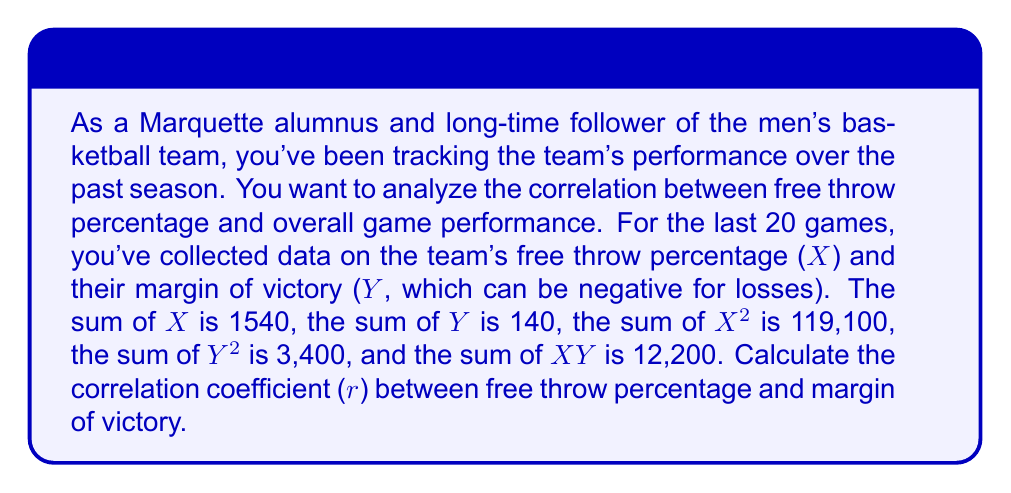Solve this math problem. To calculate the correlation coefficient (r), we'll use the formula:

$$ r = \frac{n\sum XY - \sum X \sum Y}{\sqrt{[n\sum X^2 - (\sum X)^2][n\sum Y^2 - (\sum Y)^2]}} $$

Where:
n = number of games = 20
$\sum X$ = sum of free throw percentages = 1540
$\sum Y$ = sum of margins of victory = 140
$\sum X^2$ = sum of squared free throw percentages = 119,100
$\sum Y^2$ = sum of squared margins of victory = 3,400
$\sum XY$ = sum of products of X and Y = 12,200

Let's calculate step by step:

1. Numerator:
   $20 \times 12,200 - 1540 \times 140 = 244,000 - 215,600 = 28,400$

2. Denominator part 1:
   $20 \times 119,100 - 1540^2 = 2,382,000 - 2,371,600 = 10,400$

3. Denominator part 2:
   $20 \times 3,400 - 140^2 = 68,000 - 19,600 = 48,400$

4. Complete denominator:
   $\sqrt{10,400 \times 48,400} = \sqrt{503,360,000} = 22,436.97$

5. Final calculation:
   $r = \frac{28,400}{22,436.97} = 1.2657$

6. Round to 4 decimal places:
   $r = 1.2657 \approx 1.2657$
Answer: The correlation coefficient (r) between free throw percentage and margin of victory is approximately 1.2657. 